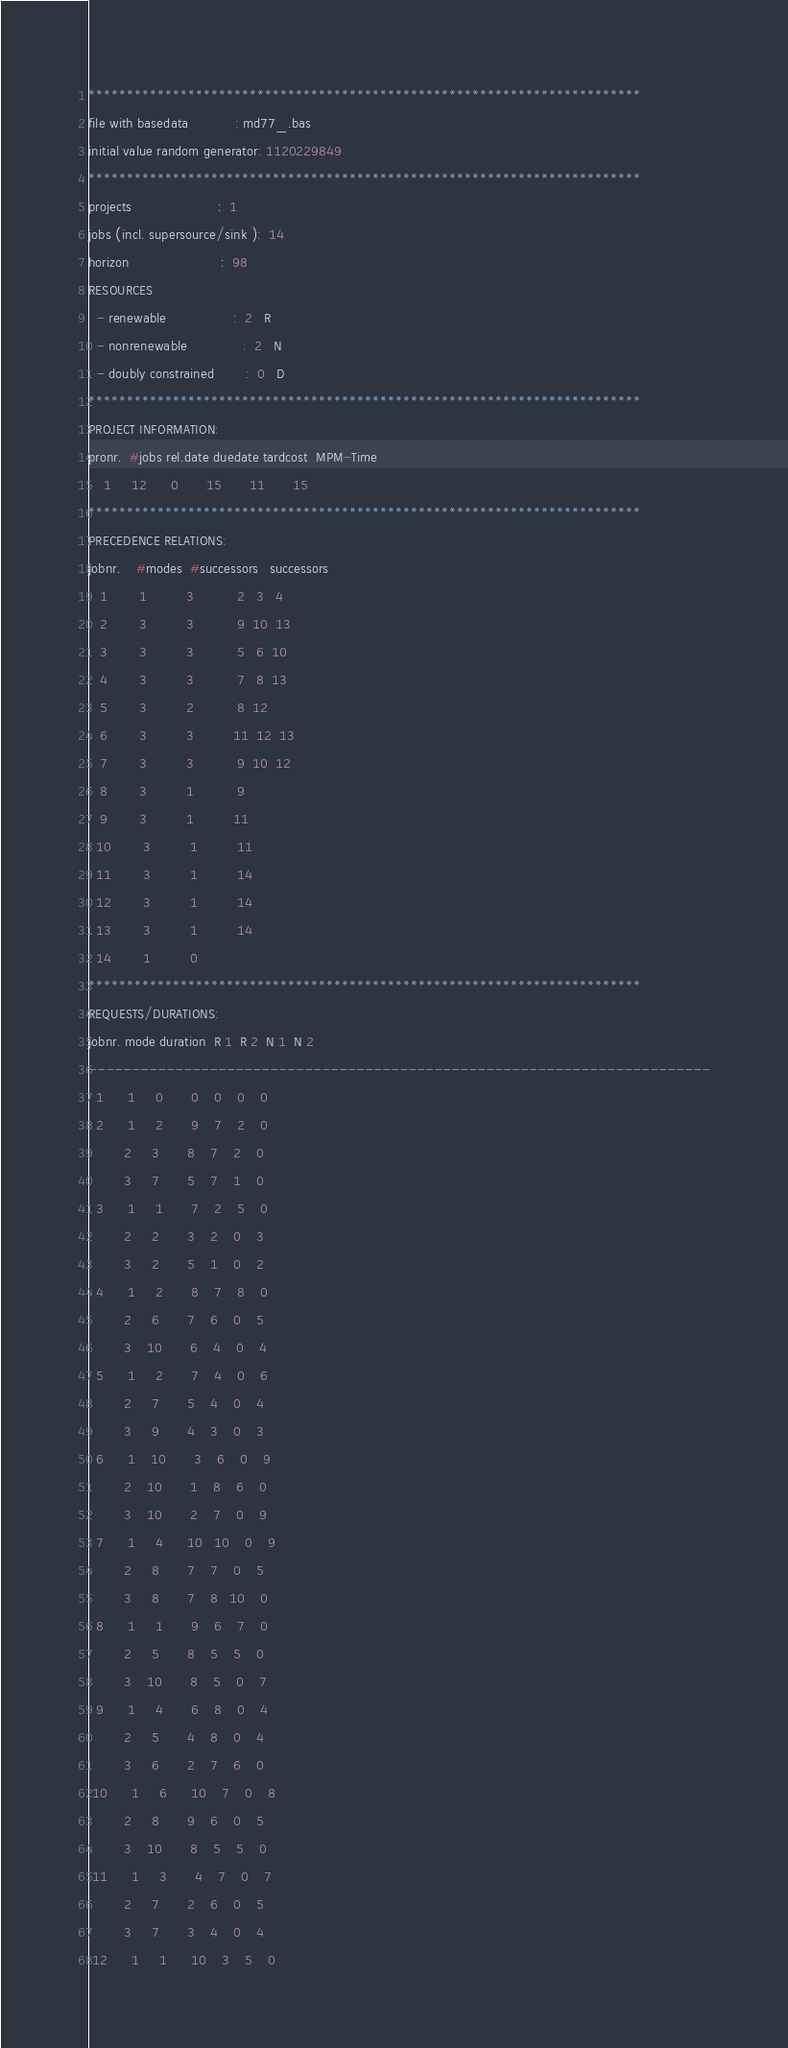<code> <loc_0><loc_0><loc_500><loc_500><_ObjectiveC_>************************************************************************
file with basedata            : md77_.bas
initial value random generator: 1120229849
************************************************************************
projects                      :  1
jobs (incl. supersource/sink ):  14
horizon                       :  98
RESOURCES
  - renewable                 :  2   R
  - nonrenewable              :  2   N
  - doubly constrained        :  0   D
************************************************************************
PROJECT INFORMATION:
pronr.  #jobs rel.date duedate tardcost  MPM-Time
    1     12      0       15       11       15
************************************************************************
PRECEDENCE RELATIONS:
jobnr.    #modes  #successors   successors
   1        1          3           2   3   4
   2        3          3           9  10  13
   3        3          3           5   6  10
   4        3          3           7   8  13
   5        3          2           8  12
   6        3          3          11  12  13
   7        3          3           9  10  12
   8        3          1           9
   9        3          1          11
  10        3          1          11
  11        3          1          14
  12        3          1          14
  13        3          1          14
  14        1          0        
************************************************************************
REQUESTS/DURATIONS:
jobnr. mode duration  R 1  R 2  N 1  N 2
------------------------------------------------------------------------
  1      1     0       0    0    0    0
  2      1     2       9    7    2    0
         2     3       8    7    2    0
         3     7       5    7    1    0
  3      1     1       7    2    5    0
         2     2       3    2    0    3
         3     2       5    1    0    2
  4      1     2       8    7    8    0
         2     6       7    6    0    5
         3    10       6    4    0    4
  5      1     2       7    4    0    6
         2     7       5    4    0    4
         3     9       4    3    0    3
  6      1    10       3    6    0    9
         2    10       1    8    6    0
         3    10       2    7    0    9
  7      1     4      10   10    0    9
         2     8       7    7    0    5
         3     8       7    8   10    0
  8      1     1       9    6    7    0
         2     5       8    5    5    0
         3    10       8    5    0    7
  9      1     4       6    8    0    4
         2     5       4    8    0    4
         3     6       2    7    6    0
 10      1     6      10    7    0    8
         2     8       9    6    0    5
         3    10       8    5    5    0
 11      1     3       4    7    0    7
         2     7       2    6    0    5
         3     7       3    4    0    4
 12      1     1      10    3    5    0</code> 